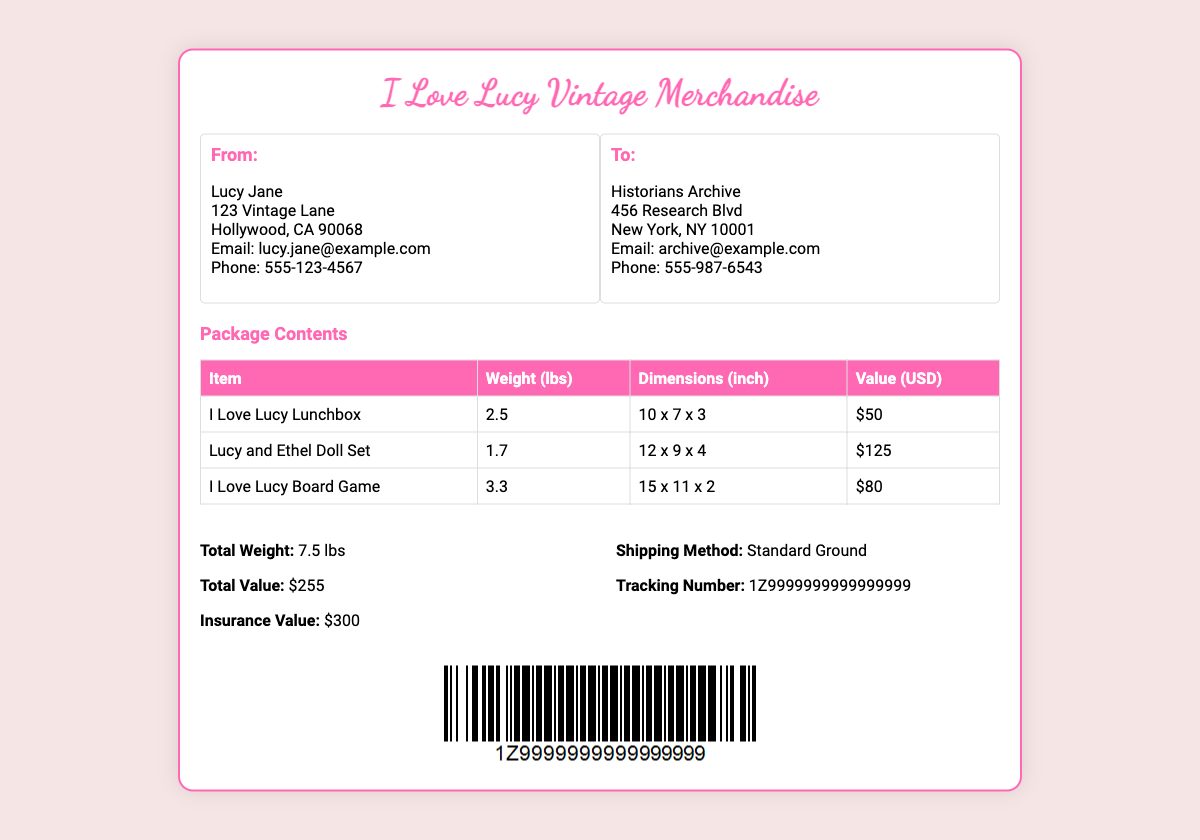what is the total weight of the package? The total weight of the package is listed in the shipping details section.
Answer: 7.5 lbs who is the sender of the package? The sender's name and address are found in the 'From:' section of the document.
Answer: Lucy Jane what is the insurance value of the package? The insurance value is specified in the shipping details section.
Answer: $300 what is the weight of the 'Lucy and Ethel Doll Set'? The weight of the 'Lucy and Ethel Doll Set' is found in the package contents table.
Answer: 1.7 lbs what is the tracking number for the shipment? The tracking number is provided in the shipping details section.
Answer: 1Z9999999999999999 what is the total value of the items being shipped? The total value is calculated from the package contents and is listed in the shipping details.
Answer: $255 what shipping method is used for this package? The shipping method can be found in the shipping details section.
Answer: Standard Ground how many items are listed in the package contents? The number of items can be counted from the rows in the package contents table.
Answer: 3 what is the email address of the historian's archive? The email address is located in the 'To:' section of the document.
Answer: archive@example.com 